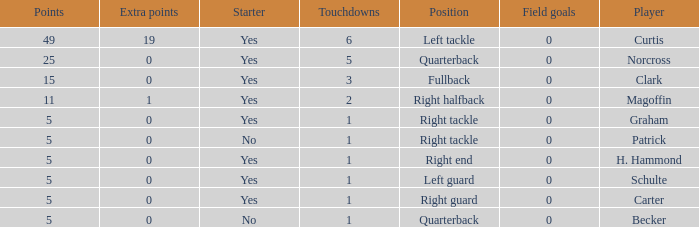Name the most touchdowns for becker  1.0. 